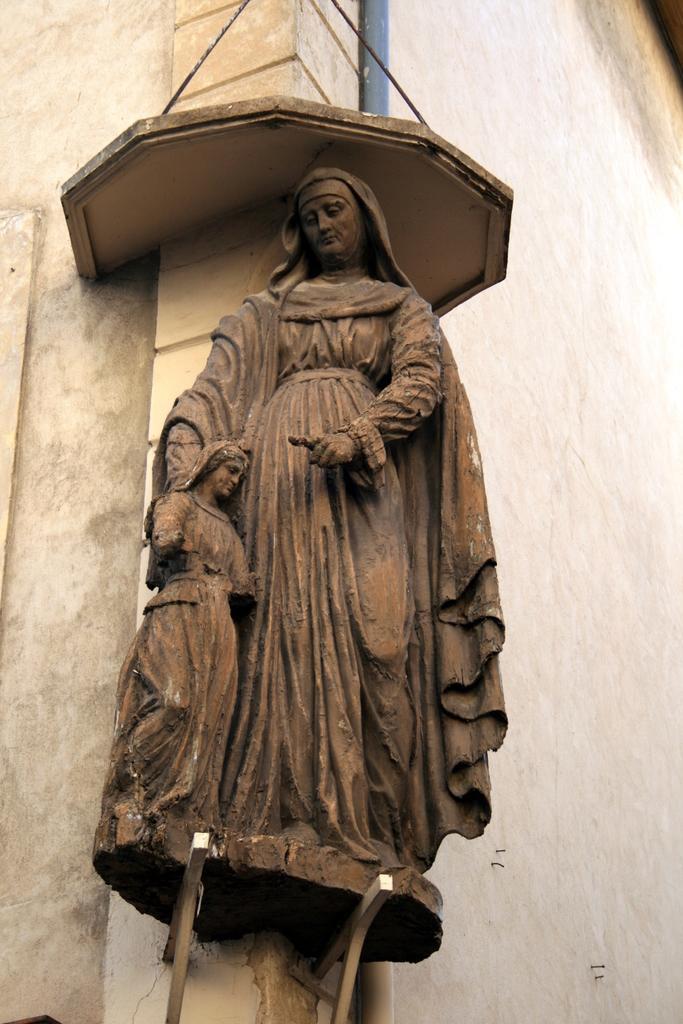Could you give a brief overview of what you see in this image? In the center of the image a statue is there. In the background of the image we can see the wall and pipe. 